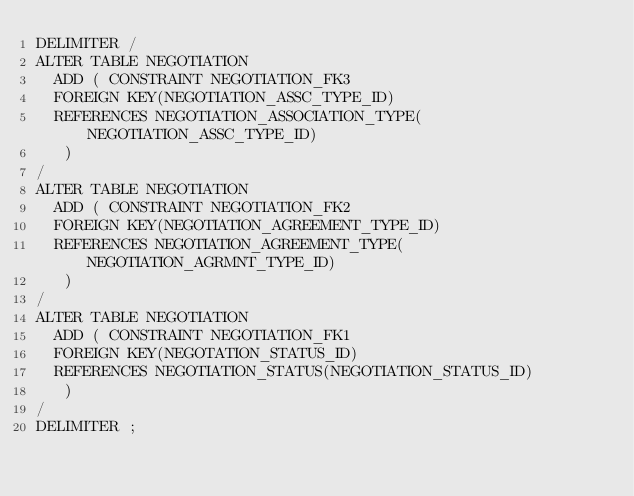Convert code to text. <code><loc_0><loc_0><loc_500><loc_500><_SQL_>DELIMITER /
ALTER TABLE NEGOTIATION
	ADD ( CONSTRAINT NEGOTIATION_FK3
	FOREIGN KEY(NEGOTIATION_ASSC_TYPE_ID)
	REFERENCES NEGOTIATION_ASSOCIATION_TYPE(NEGOTIATION_ASSC_TYPE_ID)
	 )
/
ALTER TABLE NEGOTIATION
	ADD ( CONSTRAINT NEGOTIATION_FK2
	FOREIGN KEY(NEGOTIATION_AGREEMENT_TYPE_ID)
	REFERENCES NEGOTIATION_AGREEMENT_TYPE(NEGOTIATION_AGRMNT_TYPE_ID)
	 )
/
ALTER TABLE NEGOTIATION
	ADD ( CONSTRAINT NEGOTIATION_FK1
	FOREIGN KEY(NEGOTATION_STATUS_ID)
	REFERENCES NEGOTIATION_STATUS(NEGOTIATION_STATUS_ID)
	 )
/
DELIMITER ;
</code> 